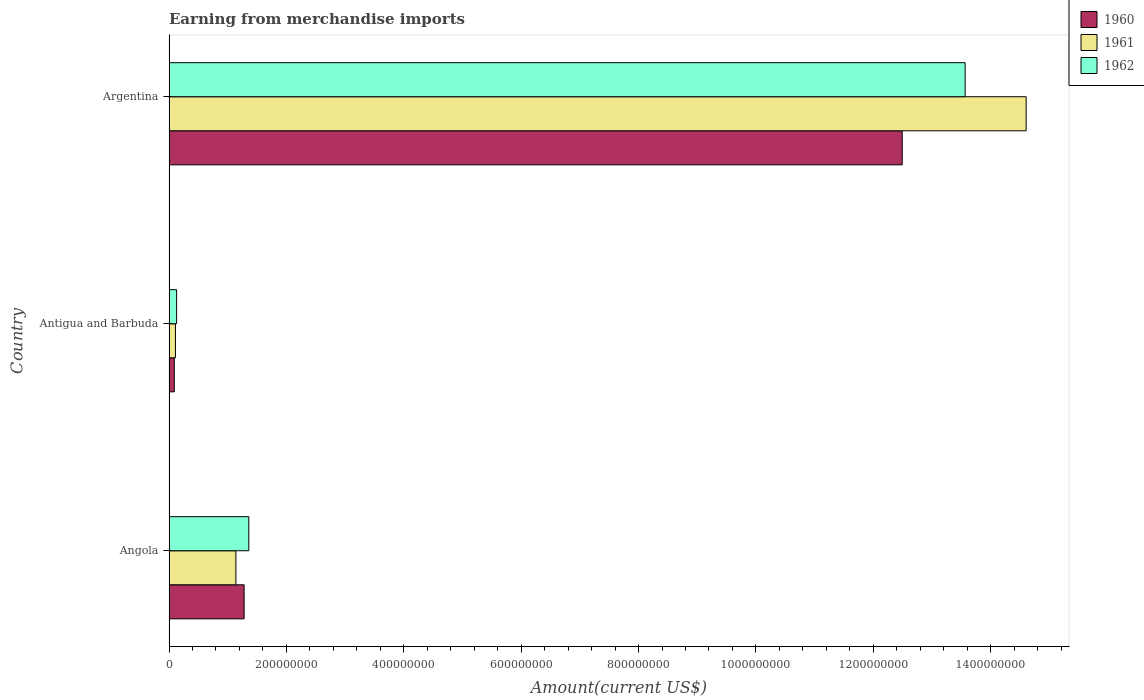How many different coloured bars are there?
Ensure brevity in your answer.  3. How many groups of bars are there?
Provide a succinct answer. 3. How many bars are there on the 2nd tick from the top?
Offer a very short reply. 3. How many bars are there on the 3rd tick from the bottom?
Offer a terse response. 3. What is the label of the 1st group of bars from the top?
Your answer should be very brief. Argentina. In how many cases, is the number of bars for a given country not equal to the number of legend labels?
Give a very brief answer. 0. What is the amount earned from merchandise imports in 1961 in Argentina?
Offer a very short reply. 1.46e+09. Across all countries, what is the maximum amount earned from merchandise imports in 1961?
Provide a succinct answer. 1.46e+09. Across all countries, what is the minimum amount earned from merchandise imports in 1962?
Give a very brief answer. 1.30e+07. In which country was the amount earned from merchandise imports in 1962 minimum?
Your answer should be compact. Antigua and Barbuda. What is the total amount earned from merchandise imports in 1960 in the graph?
Offer a very short reply. 1.39e+09. What is the difference between the amount earned from merchandise imports in 1961 in Angola and that in Argentina?
Your answer should be very brief. -1.35e+09. What is the difference between the amount earned from merchandise imports in 1961 in Argentina and the amount earned from merchandise imports in 1962 in Angola?
Provide a succinct answer. 1.32e+09. What is the average amount earned from merchandise imports in 1962 per country?
Provide a succinct answer. 5.02e+08. What is the difference between the amount earned from merchandise imports in 1962 and amount earned from merchandise imports in 1960 in Argentina?
Ensure brevity in your answer.  1.07e+08. What is the ratio of the amount earned from merchandise imports in 1962 in Angola to that in Argentina?
Offer a very short reply. 0.1. Is the difference between the amount earned from merchandise imports in 1962 in Angola and Antigua and Barbuda greater than the difference between the amount earned from merchandise imports in 1960 in Angola and Antigua and Barbuda?
Make the answer very short. Yes. What is the difference between the highest and the second highest amount earned from merchandise imports in 1960?
Your answer should be very brief. 1.12e+09. What is the difference between the highest and the lowest amount earned from merchandise imports in 1960?
Offer a very short reply. 1.24e+09. Is the sum of the amount earned from merchandise imports in 1962 in Angola and Antigua and Barbuda greater than the maximum amount earned from merchandise imports in 1961 across all countries?
Offer a terse response. No. Is it the case that in every country, the sum of the amount earned from merchandise imports in 1962 and amount earned from merchandise imports in 1960 is greater than the amount earned from merchandise imports in 1961?
Offer a terse response. Yes. How many countries are there in the graph?
Your answer should be very brief. 3. Does the graph contain any zero values?
Give a very brief answer. No. Does the graph contain grids?
Provide a succinct answer. No. How many legend labels are there?
Offer a terse response. 3. How are the legend labels stacked?
Keep it short and to the point. Vertical. What is the title of the graph?
Offer a terse response. Earning from merchandise imports. What is the label or title of the X-axis?
Ensure brevity in your answer.  Amount(current US$). What is the Amount(current US$) of 1960 in Angola?
Give a very brief answer. 1.28e+08. What is the Amount(current US$) in 1961 in Angola?
Ensure brevity in your answer.  1.14e+08. What is the Amount(current US$) in 1962 in Angola?
Provide a succinct answer. 1.36e+08. What is the Amount(current US$) in 1960 in Antigua and Barbuda?
Provide a succinct answer. 9.00e+06. What is the Amount(current US$) of 1961 in Antigua and Barbuda?
Offer a very short reply. 1.10e+07. What is the Amount(current US$) in 1962 in Antigua and Barbuda?
Your response must be concise. 1.30e+07. What is the Amount(current US$) of 1960 in Argentina?
Your answer should be very brief. 1.25e+09. What is the Amount(current US$) in 1961 in Argentina?
Your response must be concise. 1.46e+09. What is the Amount(current US$) in 1962 in Argentina?
Your response must be concise. 1.36e+09. Across all countries, what is the maximum Amount(current US$) in 1960?
Provide a succinct answer. 1.25e+09. Across all countries, what is the maximum Amount(current US$) in 1961?
Offer a very short reply. 1.46e+09. Across all countries, what is the maximum Amount(current US$) of 1962?
Your response must be concise. 1.36e+09. Across all countries, what is the minimum Amount(current US$) of 1960?
Your answer should be compact. 9.00e+06. Across all countries, what is the minimum Amount(current US$) of 1961?
Make the answer very short. 1.10e+07. Across all countries, what is the minimum Amount(current US$) in 1962?
Your response must be concise. 1.30e+07. What is the total Amount(current US$) of 1960 in the graph?
Offer a very short reply. 1.39e+09. What is the total Amount(current US$) of 1961 in the graph?
Your answer should be very brief. 1.59e+09. What is the total Amount(current US$) of 1962 in the graph?
Provide a succinct answer. 1.51e+09. What is the difference between the Amount(current US$) in 1960 in Angola and that in Antigua and Barbuda?
Offer a very short reply. 1.19e+08. What is the difference between the Amount(current US$) of 1961 in Angola and that in Antigua and Barbuda?
Ensure brevity in your answer.  1.03e+08. What is the difference between the Amount(current US$) in 1962 in Angola and that in Antigua and Barbuda?
Make the answer very short. 1.23e+08. What is the difference between the Amount(current US$) in 1960 in Angola and that in Argentina?
Offer a very short reply. -1.12e+09. What is the difference between the Amount(current US$) in 1961 in Angola and that in Argentina?
Keep it short and to the point. -1.35e+09. What is the difference between the Amount(current US$) in 1962 in Angola and that in Argentina?
Keep it short and to the point. -1.22e+09. What is the difference between the Amount(current US$) of 1960 in Antigua and Barbuda and that in Argentina?
Make the answer very short. -1.24e+09. What is the difference between the Amount(current US$) in 1961 in Antigua and Barbuda and that in Argentina?
Your answer should be compact. -1.45e+09. What is the difference between the Amount(current US$) of 1962 in Antigua and Barbuda and that in Argentina?
Your answer should be compact. -1.34e+09. What is the difference between the Amount(current US$) of 1960 in Angola and the Amount(current US$) of 1961 in Antigua and Barbuda?
Ensure brevity in your answer.  1.17e+08. What is the difference between the Amount(current US$) in 1960 in Angola and the Amount(current US$) in 1962 in Antigua and Barbuda?
Ensure brevity in your answer.  1.15e+08. What is the difference between the Amount(current US$) of 1961 in Angola and the Amount(current US$) of 1962 in Antigua and Barbuda?
Your answer should be very brief. 1.01e+08. What is the difference between the Amount(current US$) in 1960 in Angola and the Amount(current US$) in 1961 in Argentina?
Offer a very short reply. -1.33e+09. What is the difference between the Amount(current US$) of 1960 in Angola and the Amount(current US$) of 1962 in Argentina?
Your answer should be very brief. -1.23e+09. What is the difference between the Amount(current US$) of 1961 in Angola and the Amount(current US$) of 1962 in Argentina?
Make the answer very short. -1.24e+09. What is the difference between the Amount(current US$) of 1960 in Antigua and Barbuda and the Amount(current US$) of 1961 in Argentina?
Provide a succinct answer. -1.45e+09. What is the difference between the Amount(current US$) of 1960 in Antigua and Barbuda and the Amount(current US$) of 1962 in Argentina?
Ensure brevity in your answer.  -1.35e+09. What is the difference between the Amount(current US$) of 1961 in Antigua and Barbuda and the Amount(current US$) of 1962 in Argentina?
Offer a terse response. -1.35e+09. What is the average Amount(current US$) of 1960 per country?
Your answer should be compact. 4.62e+08. What is the average Amount(current US$) in 1961 per country?
Your answer should be very brief. 5.28e+08. What is the average Amount(current US$) of 1962 per country?
Provide a short and direct response. 5.02e+08. What is the difference between the Amount(current US$) in 1960 and Amount(current US$) in 1961 in Angola?
Your answer should be compact. 1.40e+07. What is the difference between the Amount(current US$) of 1960 and Amount(current US$) of 1962 in Angola?
Make the answer very short. -8.00e+06. What is the difference between the Amount(current US$) in 1961 and Amount(current US$) in 1962 in Angola?
Provide a short and direct response. -2.20e+07. What is the difference between the Amount(current US$) in 1961 and Amount(current US$) in 1962 in Antigua and Barbuda?
Your answer should be very brief. -2.00e+06. What is the difference between the Amount(current US$) in 1960 and Amount(current US$) in 1961 in Argentina?
Provide a short and direct response. -2.11e+08. What is the difference between the Amount(current US$) in 1960 and Amount(current US$) in 1962 in Argentina?
Give a very brief answer. -1.07e+08. What is the difference between the Amount(current US$) of 1961 and Amount(current US$) of 1962 in Argentina?
Provide a short and direct response. 1.04e+08. What is the ratio of the Amount(current US$) in 1960 in Angola to that in Antigua and Barbuda?
Provide a short and direct response. 14.22. What is the ratio of the Amount(current US$) in 1961 in Angola to that in Antigua and Barbuda?
Keep it short and to the point. 10.36. What is the ratio of the Amount(current US$) of 1962 in Angola to that in Antigua and Barbuda?
Your response must be concise. 10.46. What is the ratio of the Amount(current US$) of 1960 in Angola to that in Argentina?
Keep it short and to the point. 0.1. What is the ratio of the Amount(current US$) of 1961 in Angola to that in Argentina?
Provide a short and direct response. 0.08. What is the ratio of the Amount(current US$) in 1962 in Angola to that in Argentina?
Make the answer very short. 0.1. What is the ratio of the Amount(current US$) in 1960 in Antigua and Barbuda to that in Argentina?
Ensure brevity in your answer.  0.01. What is the ratio of the Amount(current US$) in 1961 in Antigua and Barbuda to that in Argentina?
Provide a short and direct response. 0.01. What is the ratio of the Amount(current US$) of 1962 in Antigua and Barbuda to that in Argentina?
Offer a very short reply. 0.01. What is the difference between the highest and the second highest Amount(current US$) of 1960?
Provide a short and direct response. 1.12e+09. What is the difference between the highest and the second highest Amount(current US$) of 1961?
Keep it short and to the point. 1.35e+09. What is the difference between the highest and the second highest Amount(current US$) in 1962?
Ensure brevity in your answer.  1.22e+09. What is the difference between the highest and the lowest Amount(current US$) in 1960?
Offer a very short reply. 1.24e+09. What is the difference between the highest and the lowest Amount(current US$) in 1961?
Ensure brevity in your answer.  1.45e+09. What is the difference between the highest and the lowest Amount(current US$) in 1962?
Keep it short and to the point. 1.34e+09. 